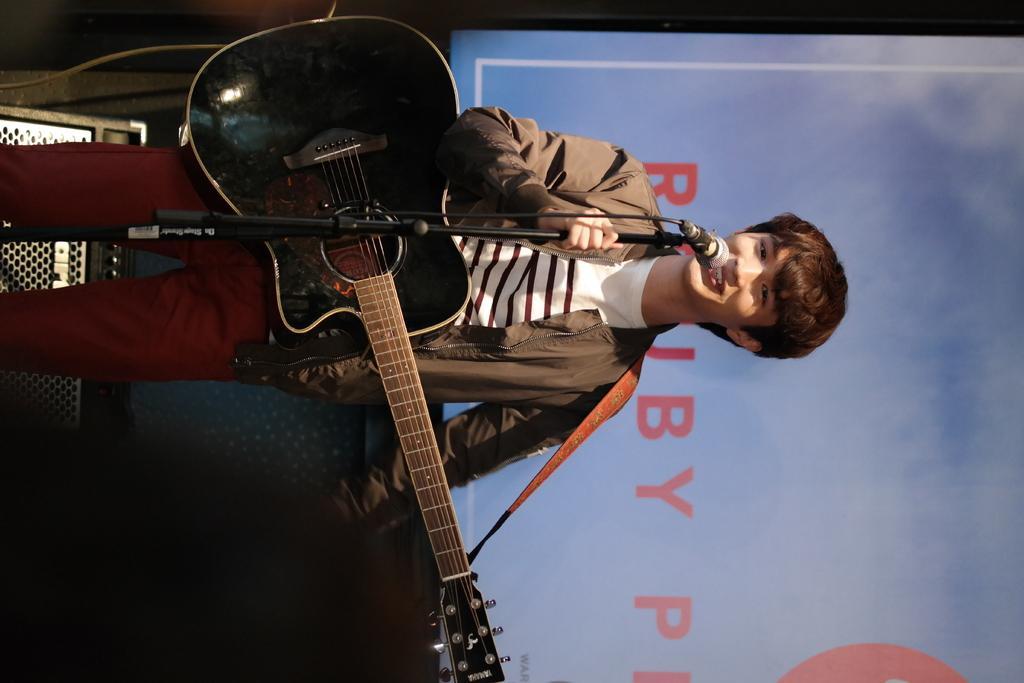Please provide a concise description of this image. In this picture we can see a person and the person is holding a guitar and a microphone, in the background we can see a screen and we can find some text on it. 